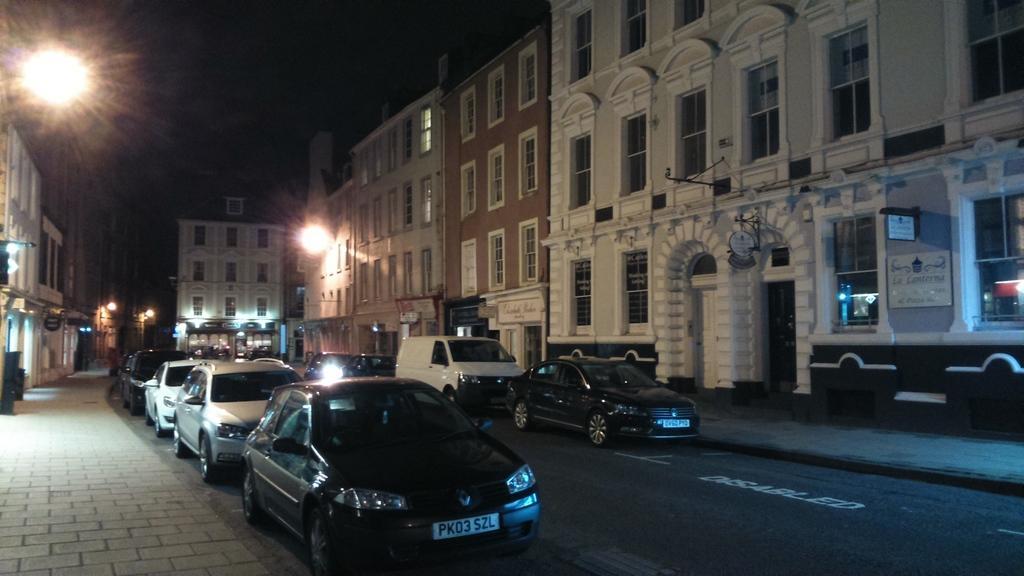Describe this image in one or two sentences. In this picture there are some black color cars on the road. In the front side we can see a white color building with glass windows. On the left side there are some cobblestone on the footpath area and some street lights. 